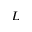Convert formula to latex. <formula><loc_0><loc_0><loc_500><loc_500>L</formula> 